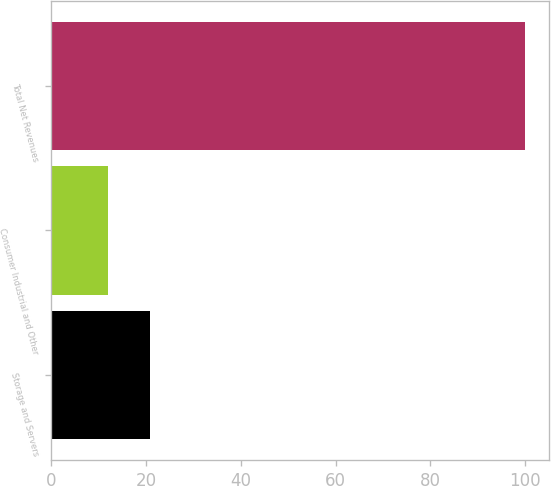<chart> <loc_0><loc_0><loc_500><loc_500><bar_chart><fcel>Storage and Servers<fcel>Consumer Industrial and Other<fcel>Total Net Revenues<nl><fcel>20.8<fcel>12<fcel>100<nl></chart> 